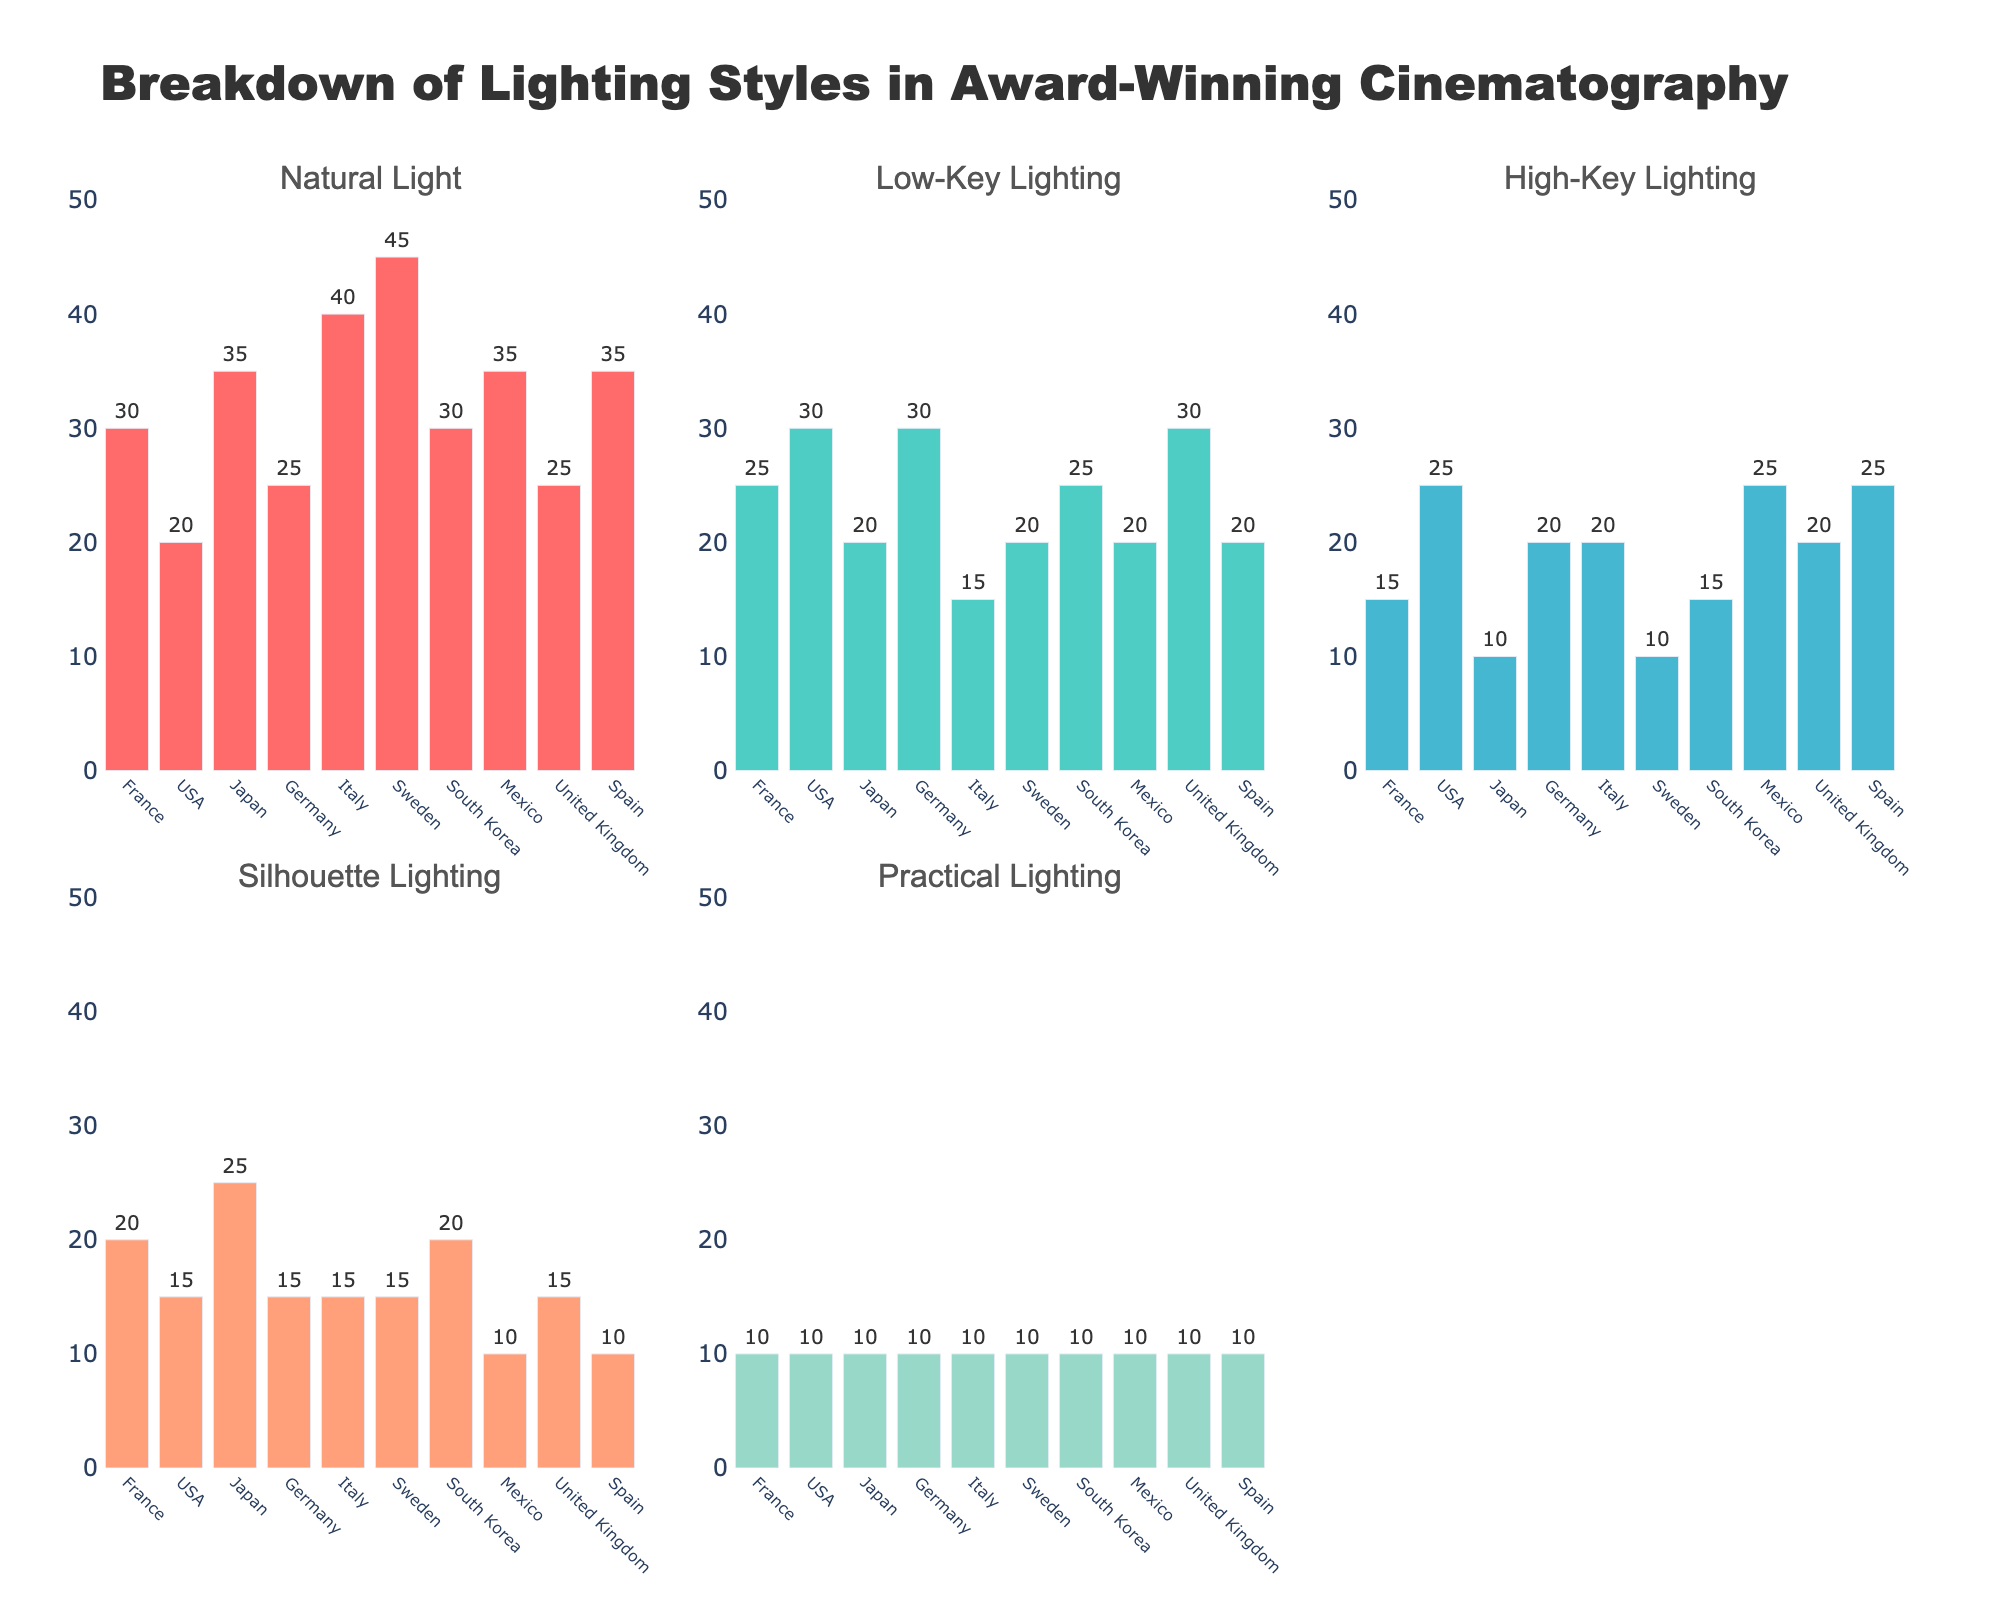What is the title of the figure? The title of the figure is displayed prominently at the top and it states, "Breakdown of Lighting Styles in Award-Winning Cinematography".
Answer: Breakdown of Lighting Styles in Award-Winning Cinematography Which country uses the most Natural Light? By observing the 'Natural Light' subplot, Sweden shows the highest bar, indicating it uses the most Natural Light.
Answer: Sweden How does the use of Low-Key Lighting in the USA compare to that in Germany? In the 'Low-Key Lighting' subplot, both the USA and Germany have bars reaching the same level, indicating equal use of Low-Key Lighting.
Answer: Equal What is the difference in the use of High-Key Lighting between Japan and Mexico? Checking the 'High-Key Lighting' subplot, Japan has a bar at 10 and Mexico at 25. So, the difference is 25 - 10 = 15.
Answer: 15 Which countries have the least variety in their lighting styles, based on the frequency of their use of lighting types? For this, observe which countries have relatively similar bar heights across all lighting styles. Italy and Spain show consistent values of 10 across multiple lighting types.
Answer: Italy and Spain Between France and South Korea, which country uses Silhouette Lighting more? In the 'Silhouette Lighting' subplot, South Korea's bar is higher than France's. Therefore, South Korea uses more Silhouette Lighting.
Answer: South Korea What is the average use of Practical Lighting across all countries? Sum the Practical Lighting values: 10 + 10 + 10 + 10 + 10 + 10 + 10 + 10 + 10 + 10 = 100. Then, divide by the number of countries (10). So, the average is 100 / 10 = 10.
Answer: 10 Which lighting style is most used overall considering all countries? Analyze each lighting style across all subplots; Natural Light consistently shows higher values across multiple countries.
Answer: Natural Light 